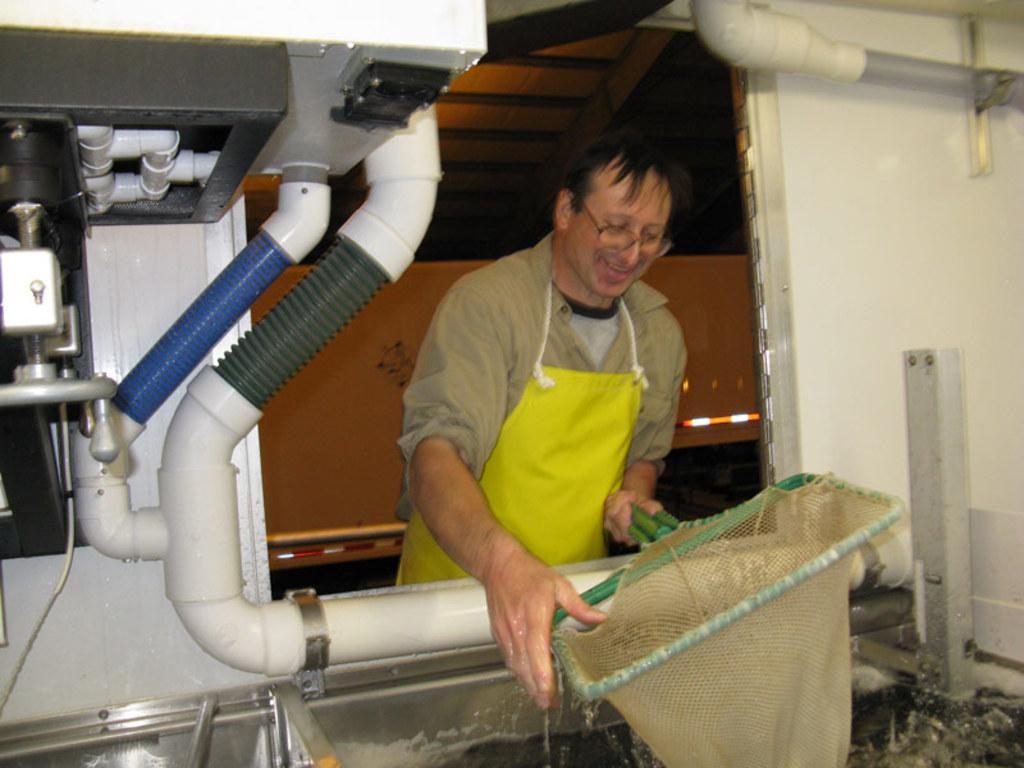How would you summarize this image in a sentence or two? In this image there is a person wearing an apron is holding a basket is having a smile on his face, beside the person there is a machine. 